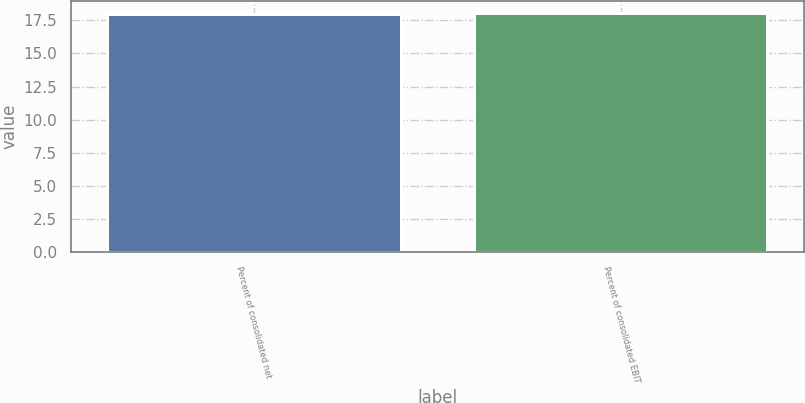<chart> <loc_0><loc_0><loc_500><loc_500><bar_chart><fcel>Percent of consolidated net<fcel>Percent of consolidated EBIT<nl><fcel>18<fcel>18.1<nl></chart> 